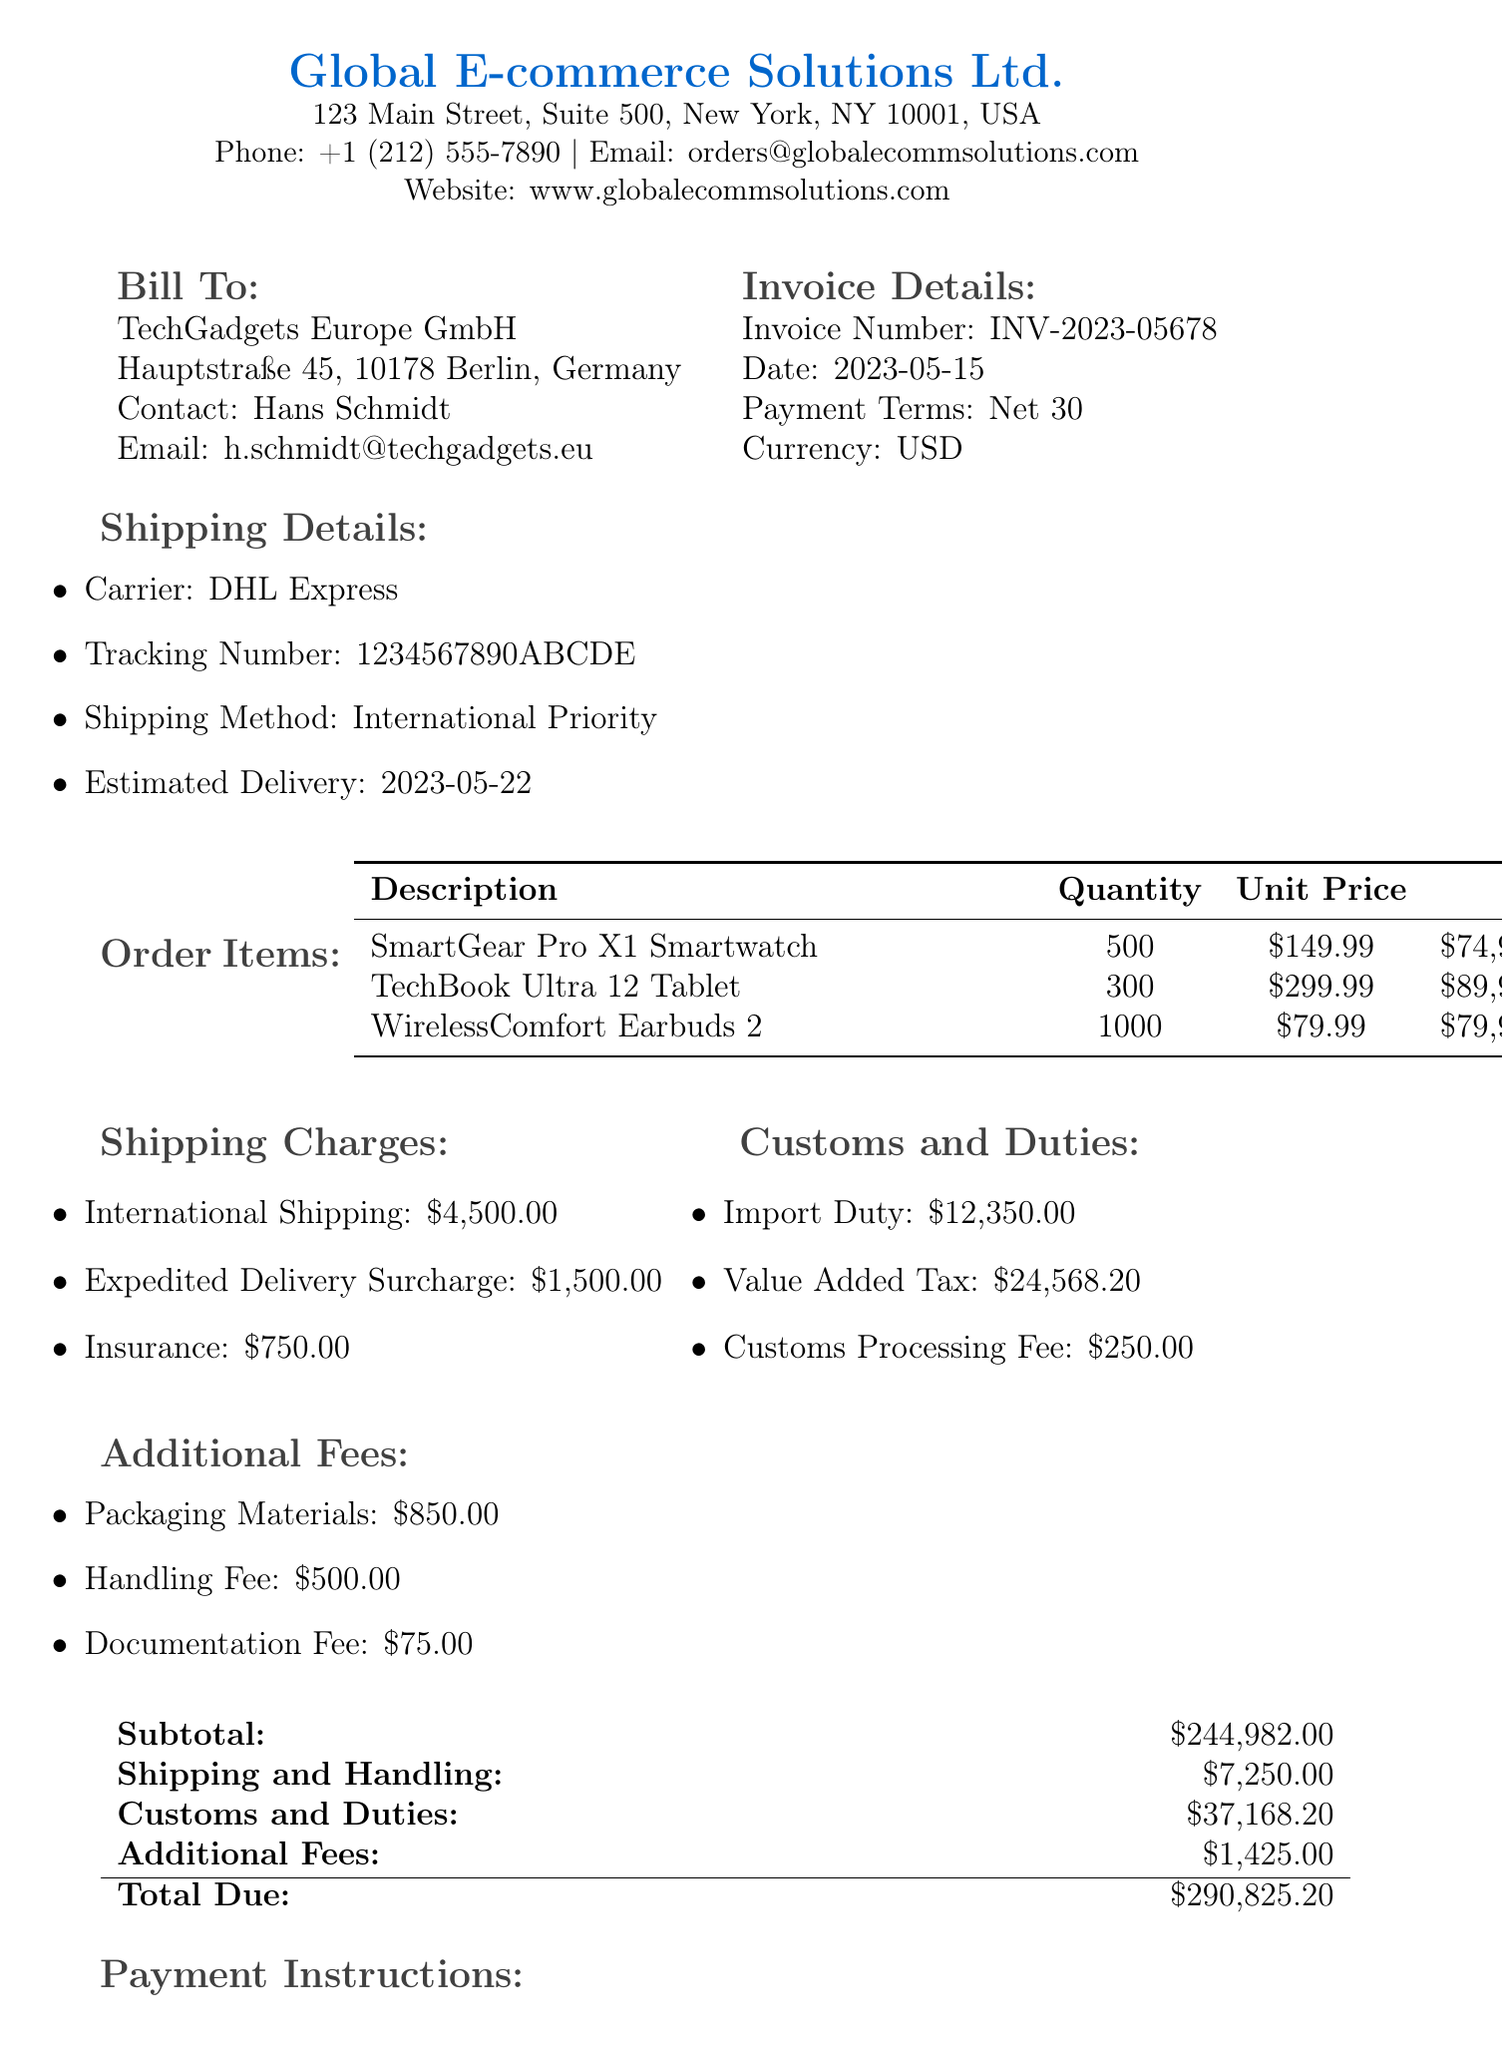what is the invoice number? The invoice number is specified in the invoice details section of the document as INV-2023-05678.
Answer: INV-2023-05678 what is the total due amount? The total due amount is found in the totals section, which sums up all charges, resulting in $290,825.20.
Answer: $290,825.20 who is the contact person for TechGadgets Europe GmbH? The contact person for TechGadgets Europe GmbH is listed in the customer info section as Hans Schmidt.
Answer: Hans Schmidt what is the estimated delivery date? The estimated delivery date is provided in the shipping details section, which indicates delivery on 2023-05-22.
Answer: 2023-05-22 how much is the import duty? The import duty is mentioned under customs and duties, listed as $12,350.00.
Answer: $12,350.00 what is the subtotal before additional fees? The subtotal before additional fees is highlighted in the totals section as $244,982.00.
Answer: $244,982.00 what is the shipping method used? The shipping method used is described in the shipping details as International Priority.
Answer: International Priority how much is the expedited delivery surcharge? The expedited delivery surcharge is specified in the shipping charges section as $1,500.00.
Answer: $1,500.00 what payment term is specified in the invoice? The payment term is stated in the invoice details section as Net 30, indicating payment is due within 30 days.
Answer: Net 30 